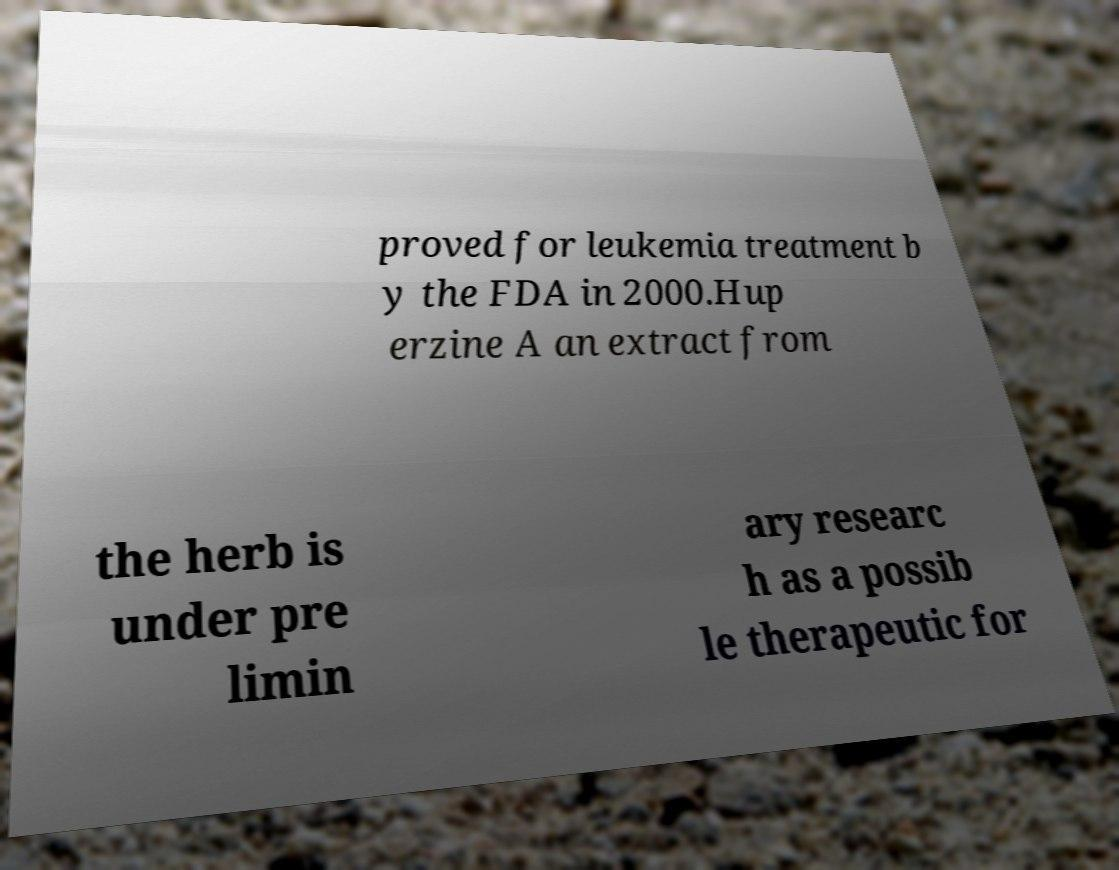I need the written content from this picture converted into text. Can you do that? proved for leukemia treatment b y the FDA in 2000.Hup erzine A an extract from the herb is under pre limin ary researc h as a possib le therapeutic for 